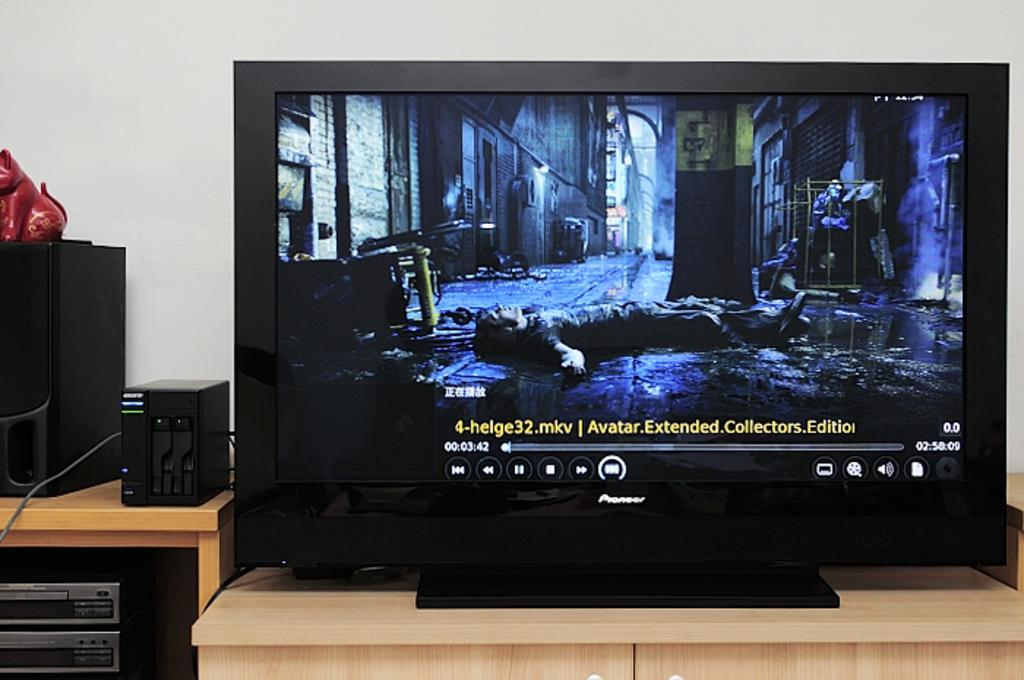Provide a one-sentence caption for the provided image. The extended collector's edition of Avatar is playing on a monitor. 